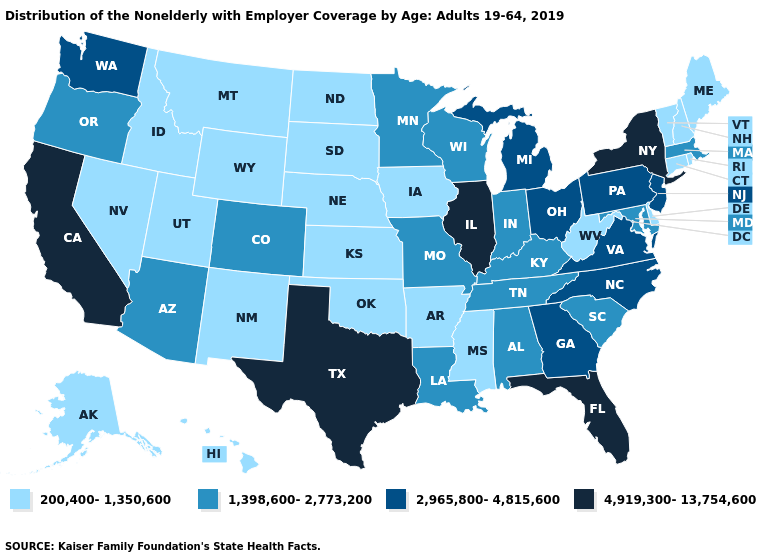Name the states that have a value in the range 2,965,800-4,815,600?
Be succinct. Georgia, Michigan, New Jersey, North Carolina, Ohio, Pennsylvania, Virginia, Washington. Among the states that border Georgia , does North Carolina have the lowest value?
Quick response, please. No. Name the states that have a value in the range 2,965,800-4,815,600?
Write a very short answer. Georgia, Michigan, New Jersey, North Carolina, Ohio, Pennsylvania, Virginia, Washington. Which states have the lowest value in the South?
Short answer required. Arkansas, Delaware, Mississippi, Oklahoma, West Virginia. What is the highest value in the MidWest ?
Be succinct. 4,919,300-13,754,600. Does Oklahoma have the lowest value in the South?
Quick response, please. Yes. Does the map have missing data?
Write a very short answer. No. Among the states that border Connecticut , which have the highest value?
Write a very short answer. New York. What is the value of Vermont?
Concise answer only. 200,400-1,350,600. Which states have the lowest value in the Northeast?
Keep it brief. Connecticut, Maine, New Hampshire, Rhode Island, Vermont. What is the highest value in states that border New Hampshire?
Quick response, please. 1,398,600-2,773,200. Name the states that have a value in the range 200,400-1,350,600?
Short answer required. Alaska, Arkansas, Connecticut, Delaware, Hawaii, Idaho, Iowa, Kansas, Maine, Mississippi, Montana, Nebraska, Nevada, New Hampshire, New Mexico, North Dakota, Oklahoma, Rhode Island, South Dakota, Utah, Vermont, West Virginia, Wyoming. Name the states that have a value in the range 1,398,600-2,773,200?
Be succinct. Alabama, Arizona, Colorado, Indiana, Kentucky, Louisiana, Maryland, Massachusetts, Minnesota, Missouri, Oregon, South Carolina, Tennessee, Wisconsin. Name the states that have a value in the range 2,965,800-4,815,600?
Give a very brief answer. Georgia, Michigan, New Jersey, North Carolina, Ohio, Pennsylvania, Virginia, Washington. What is the value of Colorado?
Concise answer only. 1,398,600-2,773,200. 